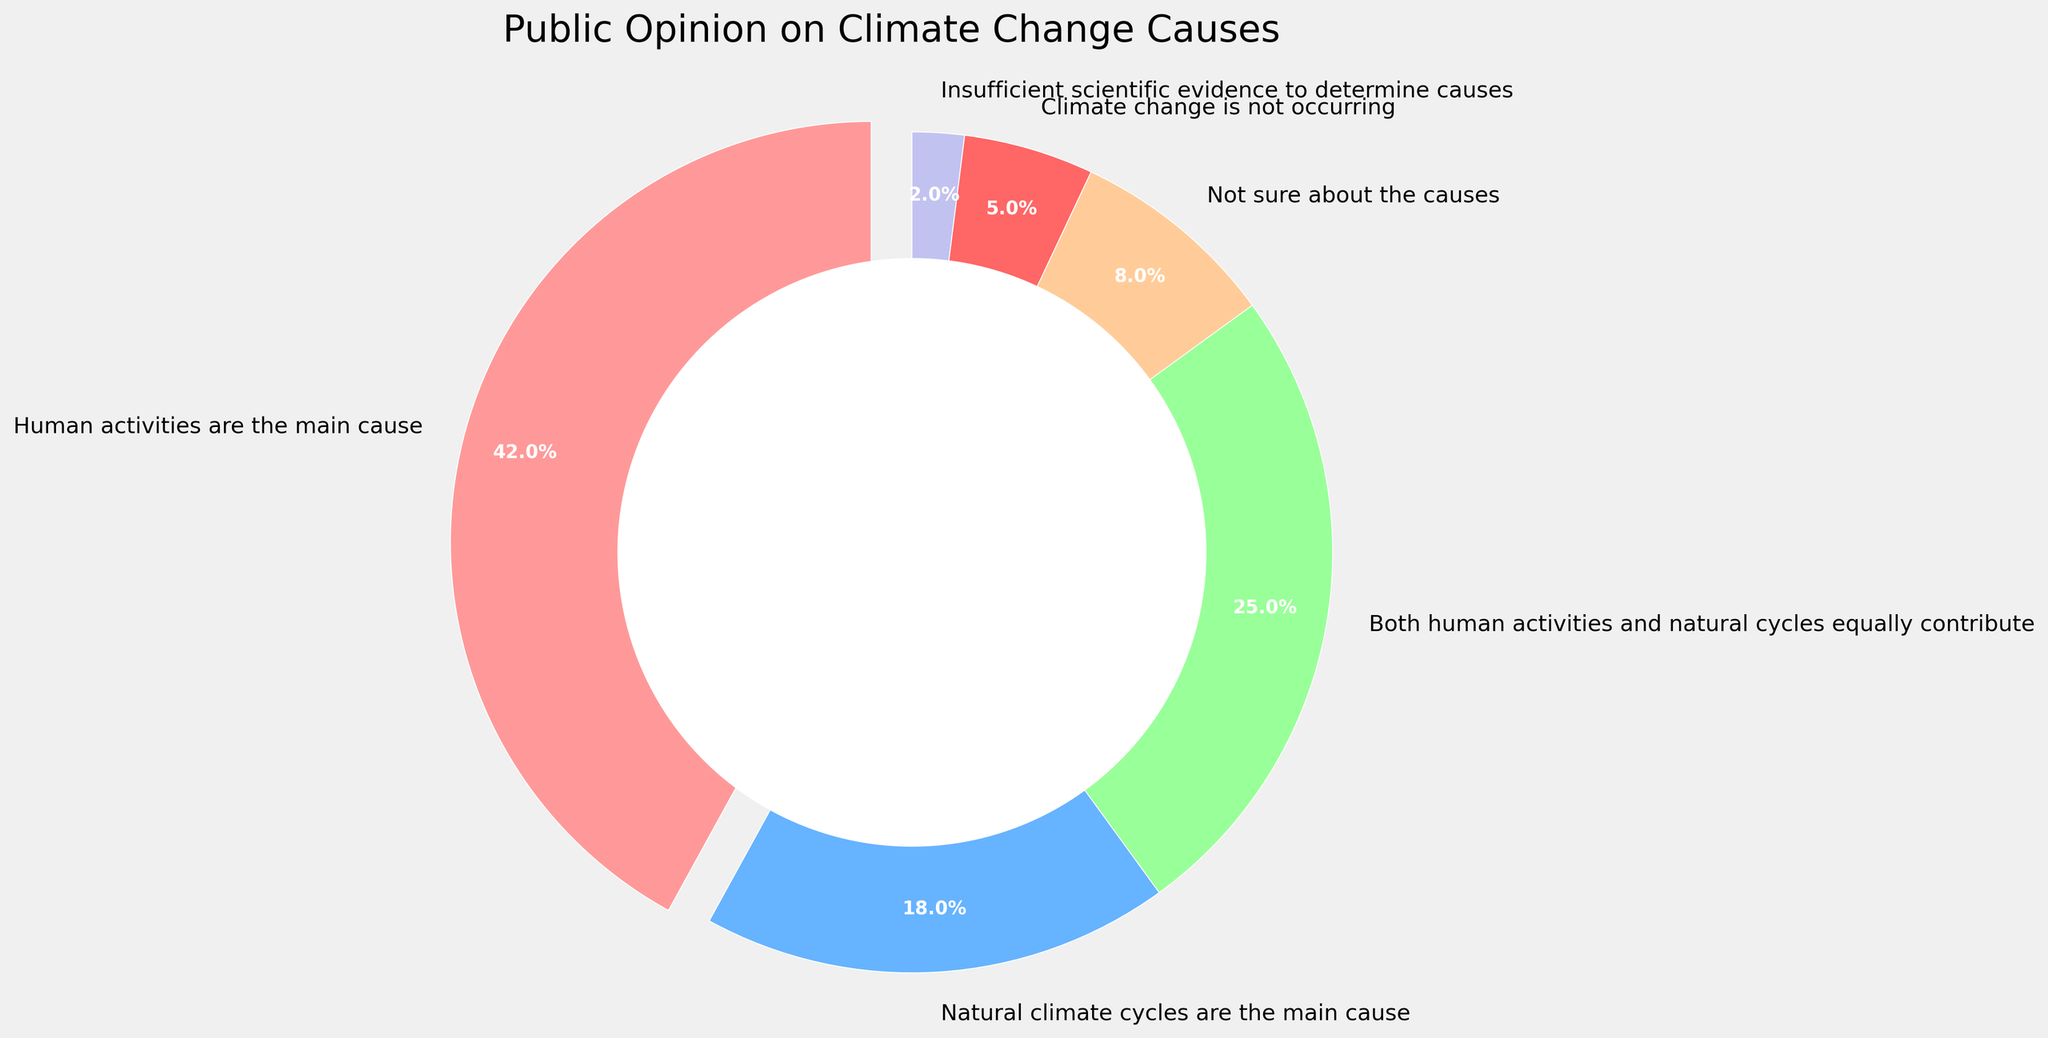What is the largest category in terms of public opinion on climate change causes? By looking at the largest wedge in the pie chart, it is evident which opinion holds the largest share. The wedge representing "Human activities are the main cause" is visually the largest.
Answer: Human activities are the main cause What is the combined percentage of people who believe either human activities or natural cycles are the main cause? Add the percentages of the people who think "Human activities are the main cause" (42%) and those who believe "Natural climate cycles are the main cause" (18%). 42 + 18 = 60.
Answer: 60% How much larger is the percentage of people who think human activities are the main cause compared to those who think climate change is not occurring? Subtract the percentage of people who think climate change is not occurring (5%) from the percentage of people who think human activities are the main cause (42%). 42 - 5 = 37.
Answer: 37% Which section of the pie chart is represented by the color red? Identify the wedge displayed in red. According to the visual cues, the red section corresponds to "Human activities are the main cause".
Answer: Human activities are the main cause Which opinions collectively account for more than 50% of the responses? Identify and sum the most significant individual percentages till the sum exceeds 50%. Combining "Human activities are the main cause" (42%) and "Both human activities and natural cycles equally contribute" (25%) results in 42 + 25 = 67.
Answer: Human activities are the main cause and Both human activities and natural cycles equally contribute What percentage of people are unsure about the causes of climate change or think there is insufficient scientific evidence? Add the percentages of people who are "Not sure about the causes" (8%) and those who see "Insufficient scientific evidence to determine causes" (2%). 8 + 2 = 10.
Answer: 10% Which opinion has the smallest representation in the pie chart? Identify the smallest wedge in the pie chart which represents "Insufficient scientific evidence to determine causes".
Answer: Insufficient scientific evidence to determine causes Compare the percentage of people who believe both human and natural factors contribute equally with those who are unsure about the causes. Compare the two percentages: "Both human activities and natural cycles equally contribute" is 25% and "Not sure about the causes" is 8%. The former is larger.
Answer: Both human activities and natural cycles equally contribute How does the percentage of people who believe natural cycles are the main cause compare to the percentage of people unsure about the causes? Compare the percentages: "Natural climate cycles are the main cause" is 18% and "Not sure about the causes" is 8%. The former is larger.
Answer: Natural climate cycles are the main cause Which categories together form the other half when combined with the opinion that human activities are the main cause? Subtract the largest category (42%) from 100 to find the remaining percentage: 100 - 42 = 58. Now, verify the combination of other categories: "Natural climate cycles are the main cause" (18%), "Both human activities and natural cycles equally contribute" (25%), "Not sure about the causes" (8%), "Climate change is not occurring" (5%), "Insufficient scientific evidence to determine causes" (2%) sum up to 58%.
Answer: Natural climate cycles are the main cause, Both human activities and natural cycles equally contribute, Not sure about the causes, Climate change is not occurring, Insufficient scientific evidence to determine causes 